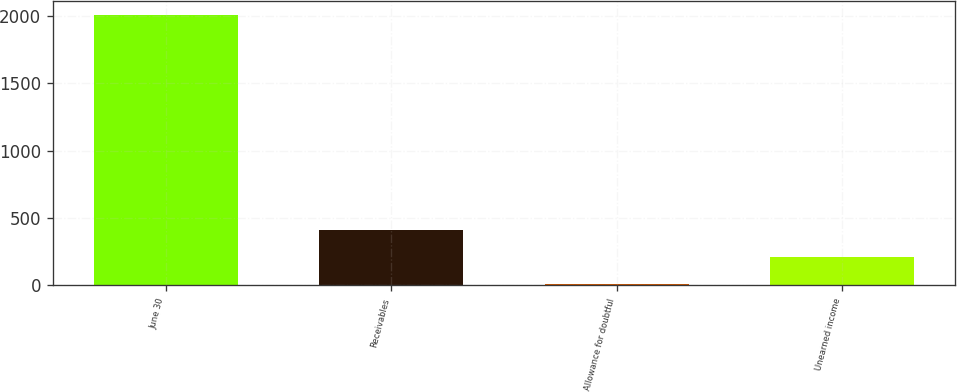<chart> <loc_0><loc_0><loc_500><loc_500><bar_chart><fcel>June 30<fcel>Receivables<fcel>Allowance for doubtful<fcel>Unearned income<nl><fcel>2009<fcel>409.72<fcel>9.9<fcel>209.81<nl></chart> 